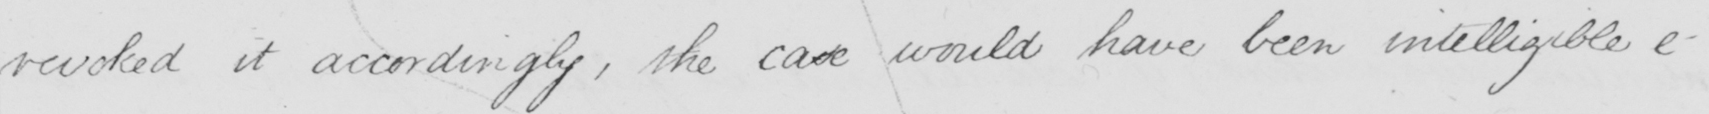What does this handwritten line say? revoked it accordingly , the case would have been intelligible e- 